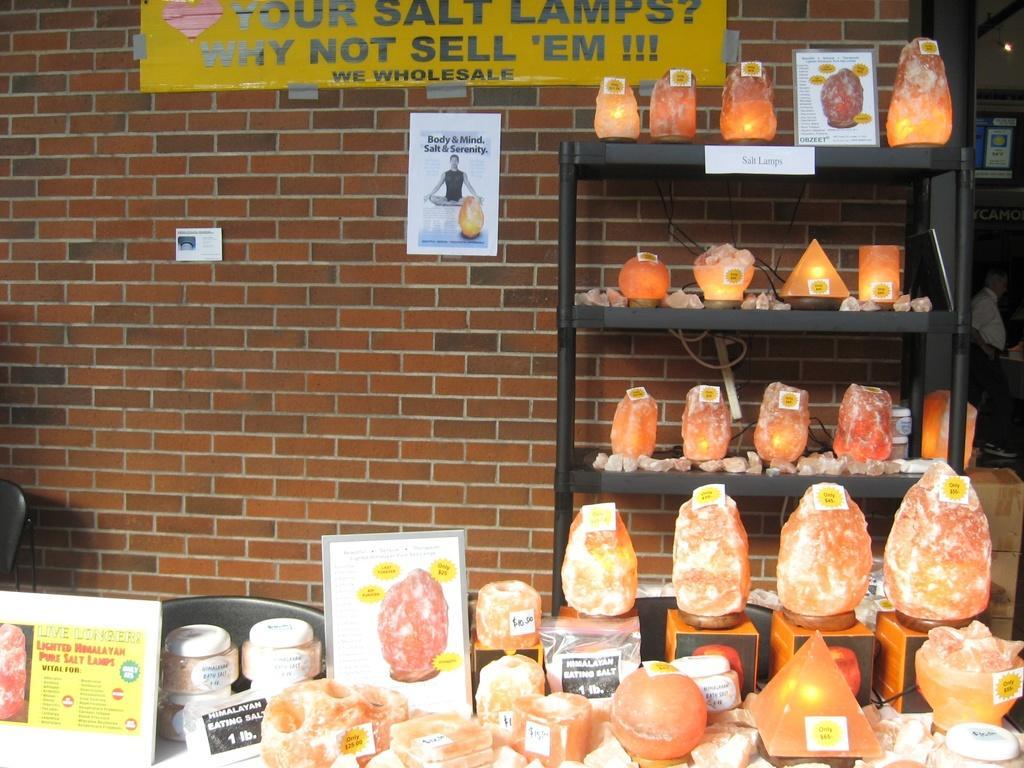Can you describe this image briefly? In this image I can see few boards, jars. Background I can see few objects in orange color and they are on the racks and I can see the yellow color board attached to the wall and the wall is in brown color. 